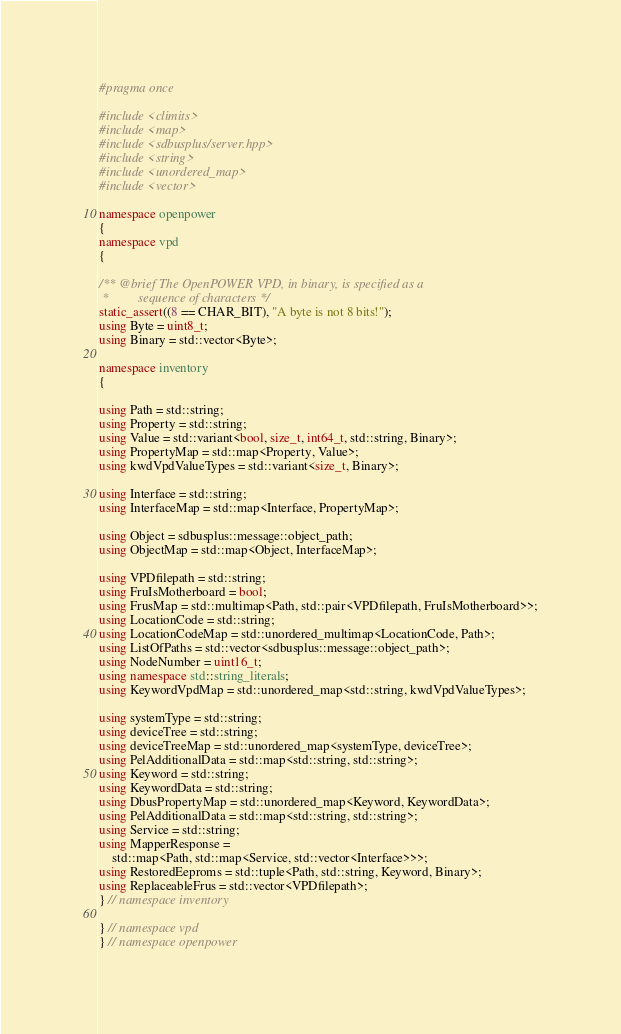Convert code to text. <code><loc_0><loc_0><loc_500><loc_500><_C++_>#pragma once

#include <climits>
#include <map>
#include <sdbusplus/server.hpp>
#include <string>
#include <unordered_map>
#include <vector>

namespace openpower
{
namespace vpd
{

/** @brief The OpenPOWER VPD, in binary, is specified as a
 *         sequence of characters */
static_assert((8 == CHAR_BIT), "A byte is not 8 bits!");
using Byte = uint8_t;
using Binary = std::vector<Byte>;

namespace inventory
{

using Path = std::string;
using Property = std::string;
using Value = std::variant<bool, size_t, int64_t, std::string, Binary>;
using PropertyMap = std::map<Property, Value>;
using kwdVpdValueTypes = std::variant<size_t, Binary>;

using Interface = std::string;
using InterfaceMap = std::map<Interface, PropertyMap>;

using Object = sdbusplus::message::object_path;
using ObjectMap = std::map<Object, InterfaceMap>;

using VPDfilepath = std::string;
using FruIsMotherboard = bool;
using FrusMap = std::multimap<Path, std::pair<VPDfilepath, FruIsMotherboard>>;
using LocationCode = std::string;
using LocationCodeMap = std::unordered_multimap<LocationCode, Path>;
using ListOfPaths = std::vector<sdbusplus::message::object_path>;
using NodeNumber = uint16_t;
using namespace std::string_literals;
using KeywordVpdMap = std::unordered_map<std::string, kwdVpdValueTypes>;

using systemType = std::string;
using deviceTree = std::string;
using deviceTreeMap = std::unordered_map<systemType, deviceTree>;
using PelAdditionalData = std::map<std::string, std::string>;
using Keyword = std::string;
using KeywordData = std::string;
using DbusPropertyMap = std::unordered_map<Keyword, KeywordData>;
using PelAdditionalData = std::map<std::string, std::string>;
using Service = std::string;
using MapperResponse =
    std::map<Path, std::map<Service, std::vector<Interface>>>;
using RestoredEeproms = std::tuple<Path, std::string, Keyword, Binary>;
using ReplaceableFrus = std::vector<VPDfilepath>;
} // namespace inventory

} // namespace vpd
} // namespace openpower</code> 